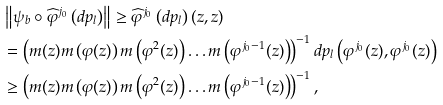<formula> <loc_0><loc_0><loc_500><loc_500>& \left \| \psi _ { b } \circ \widehat { \varphi } ^ { j _ { 0 } } \left ( d p _ { l } \right ) \right \| \geq \widehat { \varphi } ^ { j _ { 0 } } \left ( d p _ { l } \right ) ( z , z ) \\ & = \left ( m ( z ) m \left ( \varphi ( z ) \right ) m \left ( \varphi ^ { 2 } ( z ) \right ) \dots m \left ( \varphi ^ { j _ { 0 } - 1 } ( z ) \right ) \right ) ^ { - 1 } d p _ { l } \left ( \varphi ^ { j _ { 0 } } ( z ) , \varphi ^ { j _ { 0 } } ( z ) \right ) \\ & \geq \left ( m ( z ) m \left ( \varphi ( z ) \right ) m \left ( \varphi ^ { 2 } ( z ) \right ) \dots m \left ( \varphi ^ { j _ { 0 } - 1 } ( z ) \right ) \right ) ^ { - 1 } ,</formula> 